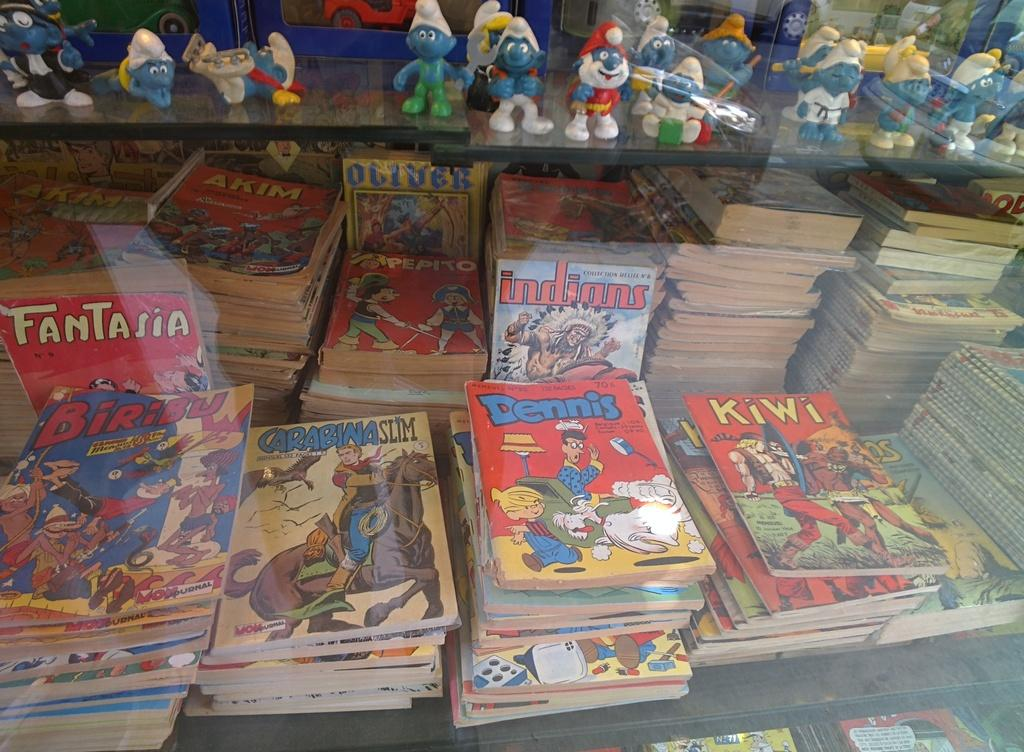<image>
Describe the image concisely. Stacks of comic books with the titles Dennis, Kiwi, Baribu, and Fantasia among many others. 